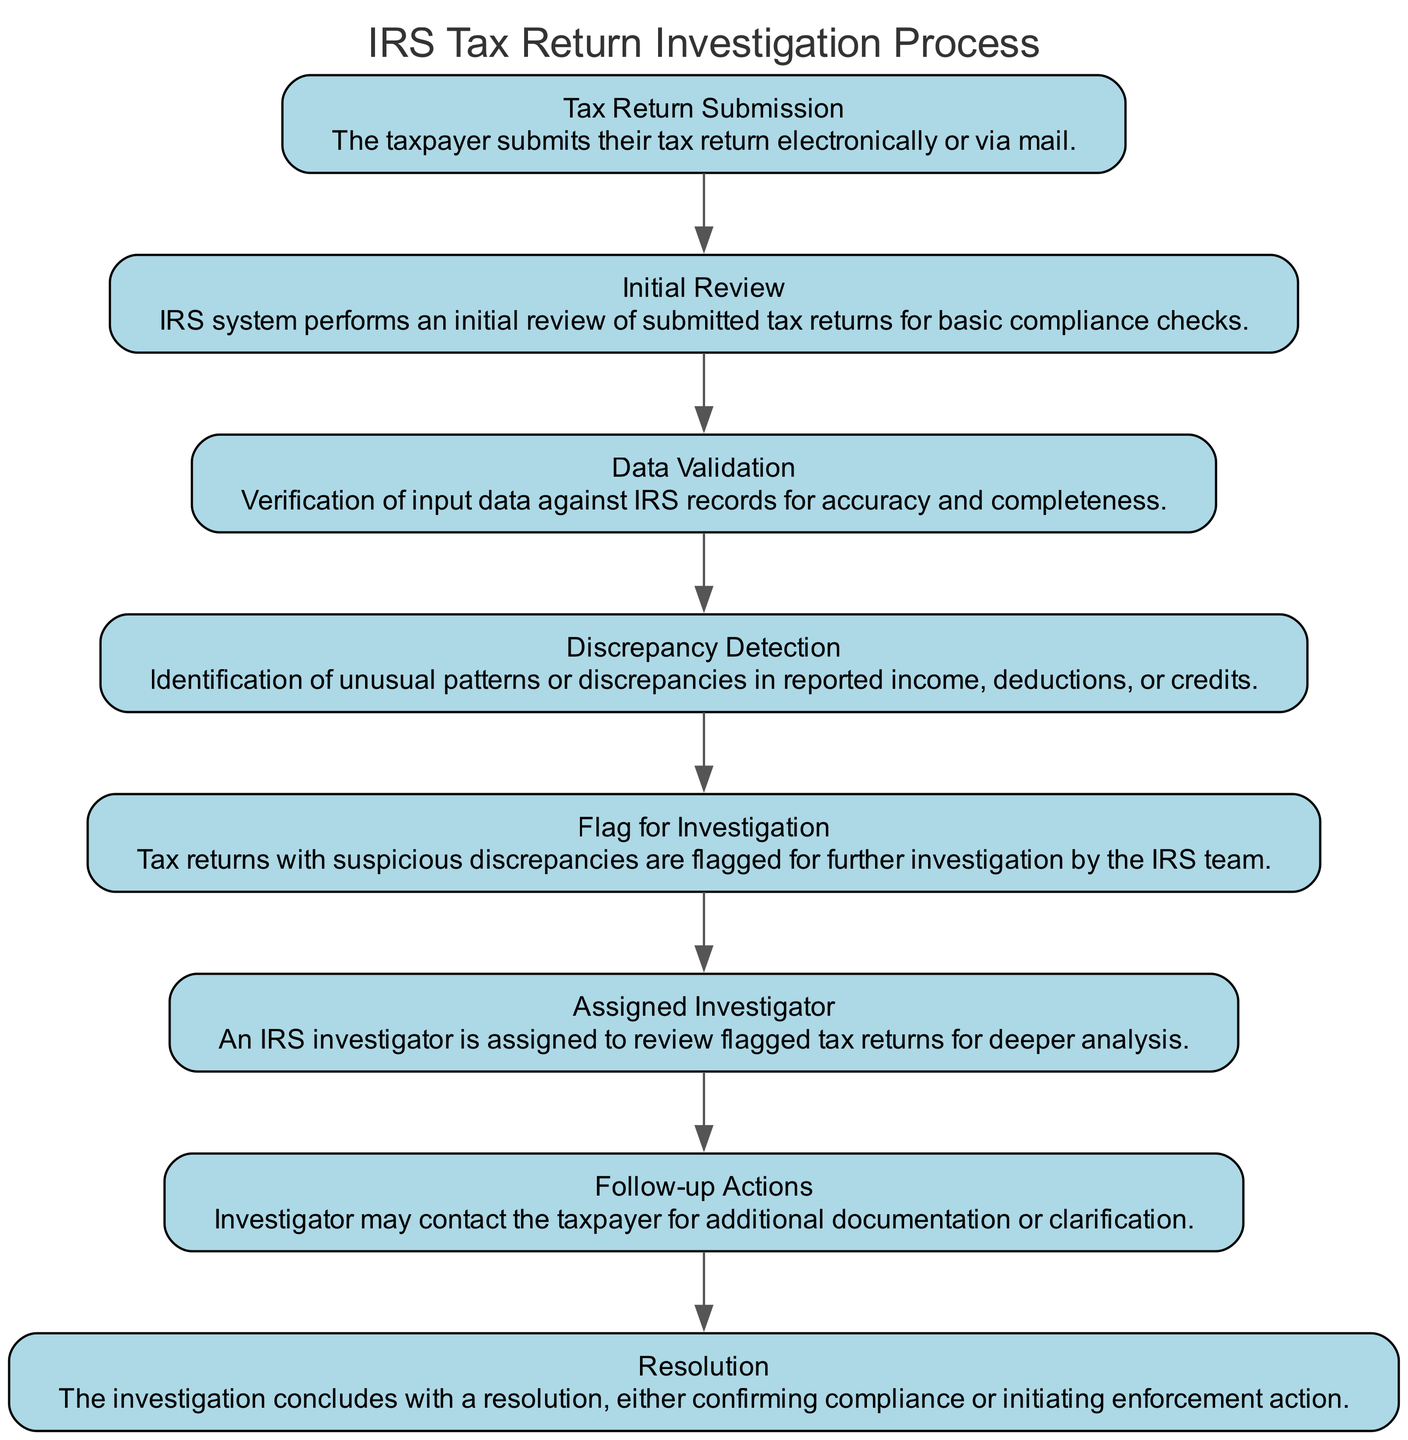What is the first step in the diagram? The first step is "Tax Return Submission," where the taxpayer submits their tax return electronically or via mail.
Answer: Tax Return Submission How many nodes are present in the diagram? Each element in the diagram represents a node, and there are eight distinct elements listed.
Answer: Eight What is the node that follows "Data Validation"? The node that follows "Data Validation" is "Discrepancy Detection," where unusual patterns or discrepancies in reported data are identified.
Answer: Discrepancy Detection Which element leads to the "Resolution" node? The "Follow-up Actions" element leads to the "Resolution" node, indicating that actions taken after an investigation can lead to a final resolution.
Answer: Follow-up Actions What is the purpose of the "Flag for Investigation" step? The purpose of the "Flag for Investigation" step is to signal that tax returns with suspicious discrepancies require further investigation by the IRS team.
Answer: To indicate further investigation needs What transformation occurs between "Discrepancy Detection" and "Assigned Investigator"? The transformation involves flagging the suspicious tax returns identified during "Discrepancy Detection" to assign an investigator for deeper analysis.
Answer: Flagging for investigation If a tax return is flagged, what is the next immediate action? If a tax return is flagged, the next immediate action is "Assigned Investigator," who will review the flagged tax returns.
Answer: Assigned Investigator What does the "Initial Review" step assess? The "Initial Review" step assesses submitted tax returns for basic compliance checks before moving to data validation.
Answer: Basic compliance checks Which node indicates potential further communication with the taxpayer? The node indicating potential further communication with the taxpayer is "Follow-up Actions," where the investigator may contact the taxpayer for documentation or clarification.
Answer: Follow-up Actions 